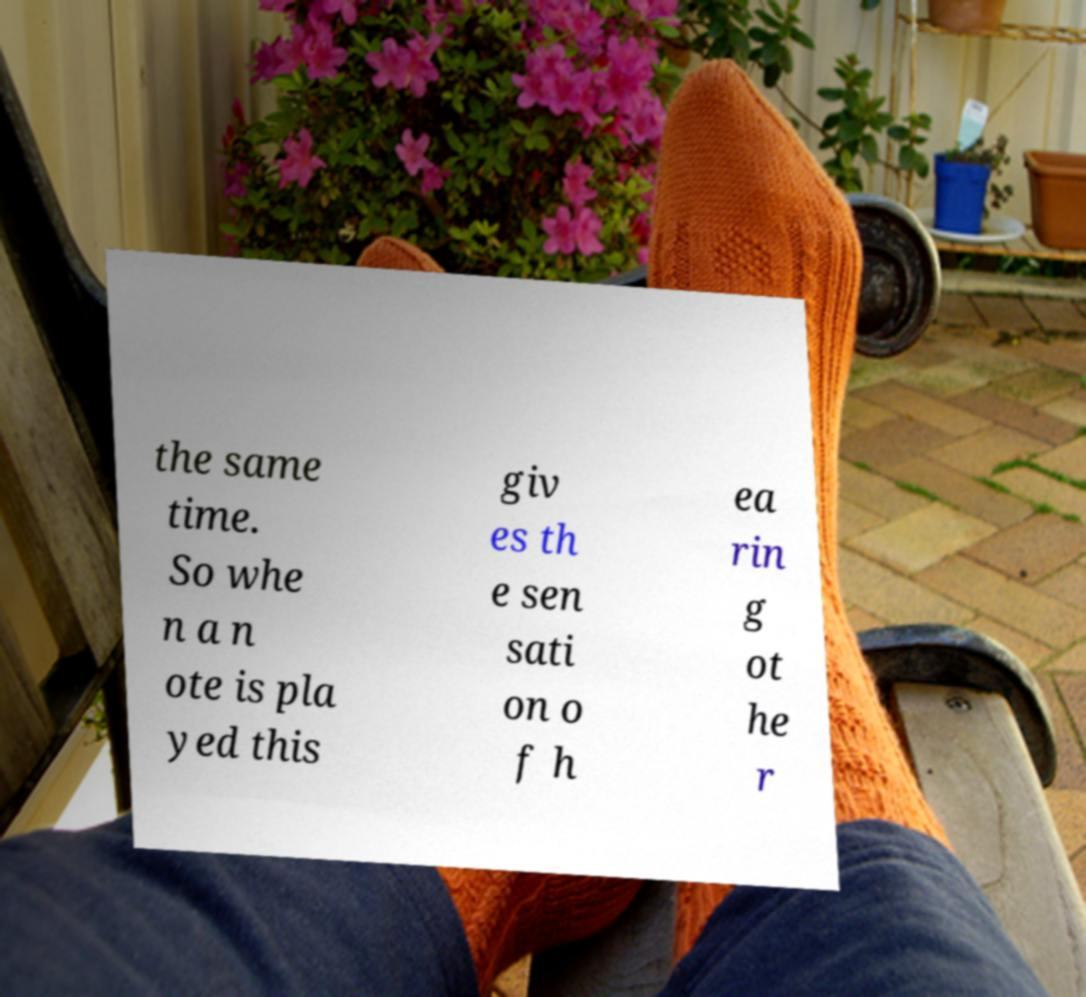Can you read and provide the text displayed in the image?This photo seems to have some interesting text. Can you extract and type it out for me? the same time. So whe n a n ote is pla yed this giv es th e sen sati on o f h ea rin g ot he r 